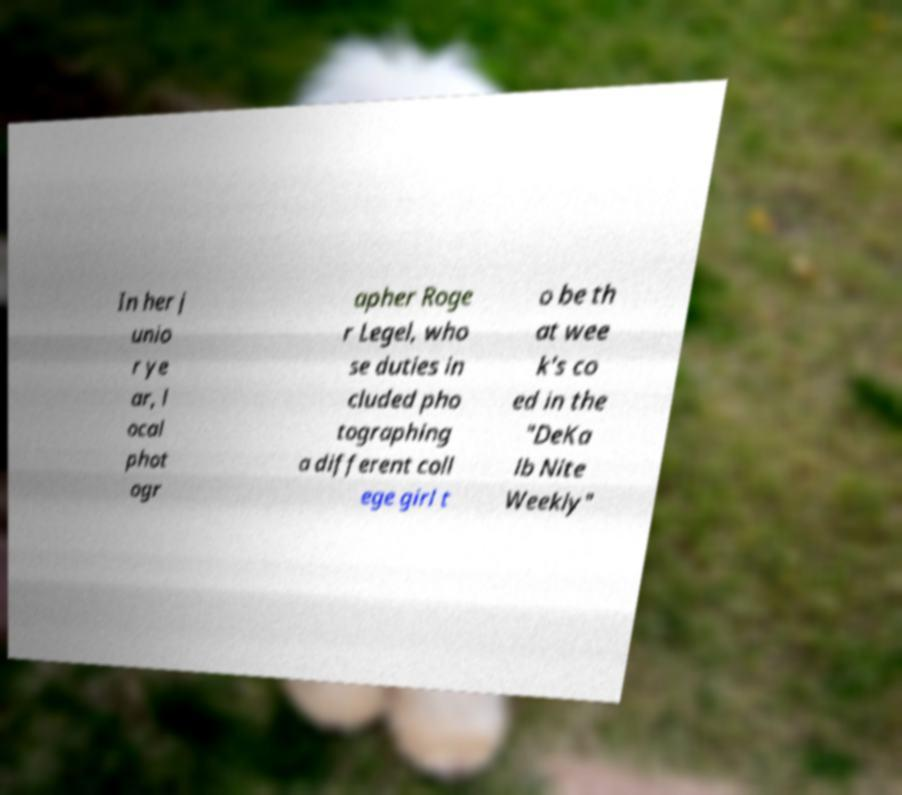I need the written content from this picture converted into text. Can you do that? In her j unio r ye ar, l ocal phot ogr apher Roge r Legel, who se duties in cluded pho tographing a different coll ege girl t o be th at wee k's co ed in the "DeKa lb Nite Weekly" 